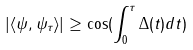Convert formula to latex. <formula><loc_0><loc_0><loc_500><loc_500>| \langle \psi , \psi _ { \tau } \rangle | \geq \cos ( \int ^ { \tau } _ { 0 } \Delta ( t ) d t )</formula> 